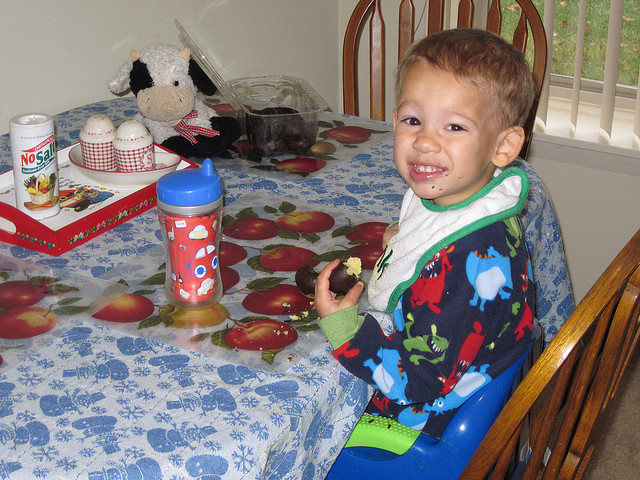<image>What image or pattern is on the baby's bib? I don't know what exact image or pattern is on the baby's bib. It can possibly be solid, bird, letters, monsters, creatures or dinosaur. What image or pattern is on the baby's bib? I don't know what image or pattern is on the baby's bib. It can be 'grass', 'bird', 'letters', 'monsters', 'space', 'solid', 'creatures', 'dinosaur' or none. 